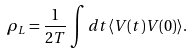Convert formula to latex. <formula><loc_0><loc_0><loc_500><loc_500>\rho _ { L } = \frac { 1 } { 2 T } \int d t \langle V ( t ) V ( 0 ) \rangle .</formula> 